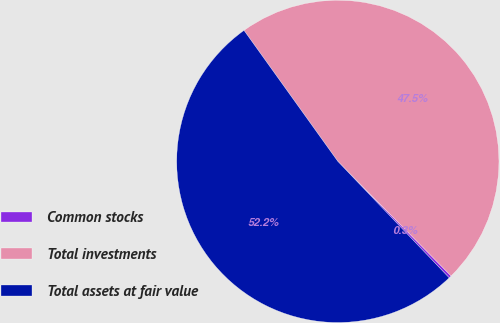Convert chart. <chart><loc_0><loc_0><loc_500><loc_500><pie_chart><fcel>Common stocks<fcel>Total investments<fcel>Total assets at fair value<nl><fcel>0.27%<fcel>47.48%<fcel>52.25%<nl></chart> 